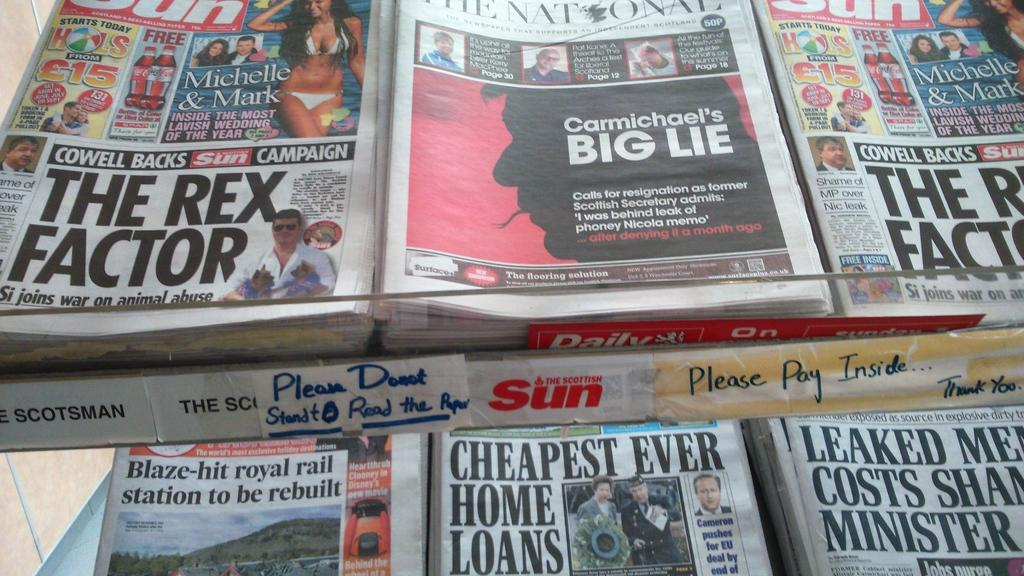<image>
Offer a succinct explanation of the picture presented. A newspaper stand with copies of the sun and the national 